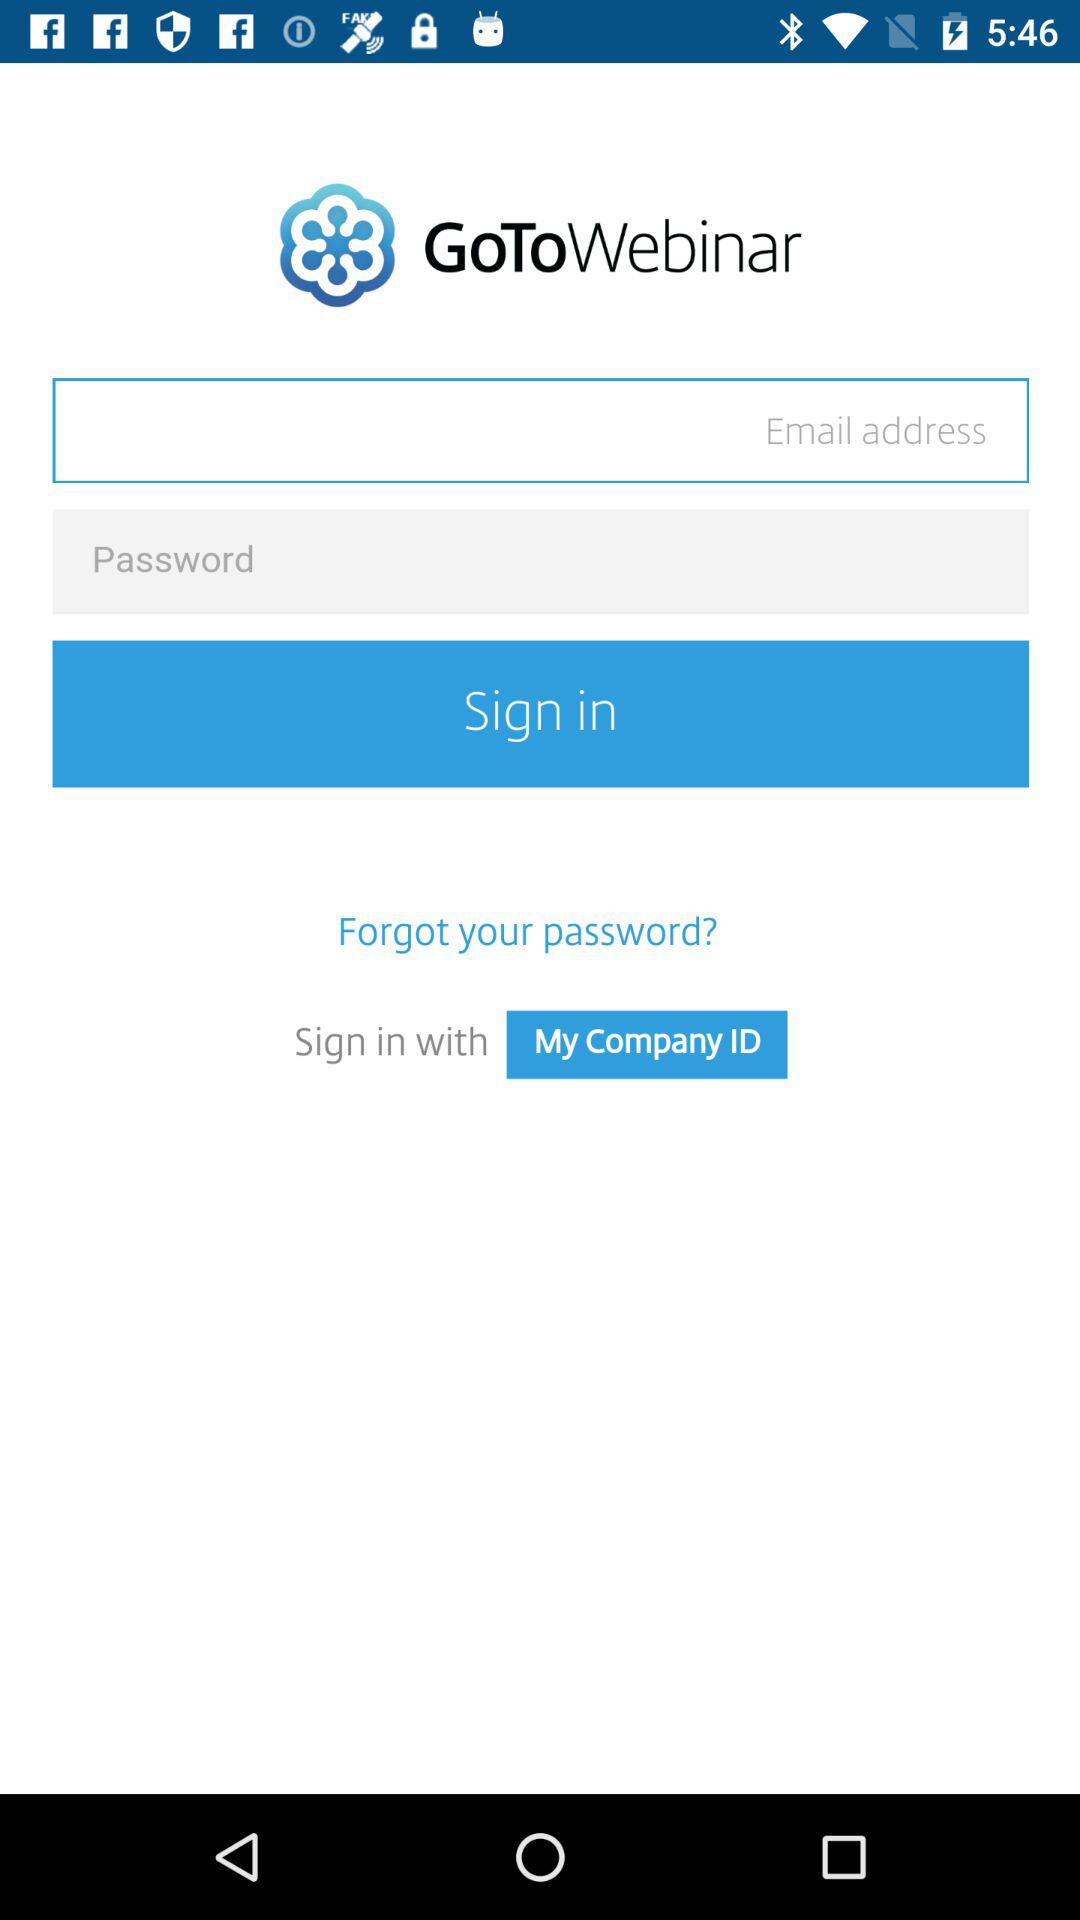How many inputs are there in the login form?
Answer the question using a single word or phrase. 2 